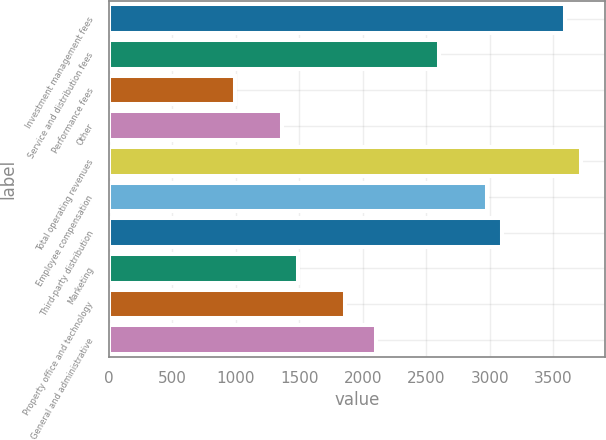Convert chart. <chart><loc_0><loc_0><loc_500><loc_500><bar_chart><fcel>Investment management fees<fcel>Service and distribution fees<fcel>Performance fees<fcel>Other<fcel>Total operating revenues<fcel>Employee compensation<fcel>Third-party distribution<fcel>Marketing<fcel>Property office and technology<fcel>General and administrative<nl><fcel>3594.53<fcel>2603.01<fcel>991.79<fcel>1363.61<fcel>3718.47<fcel>2974.83<fcel>3098.77<fcel>1487.55<fcel>1859.37<fcel>2107.25<nl></chart> 